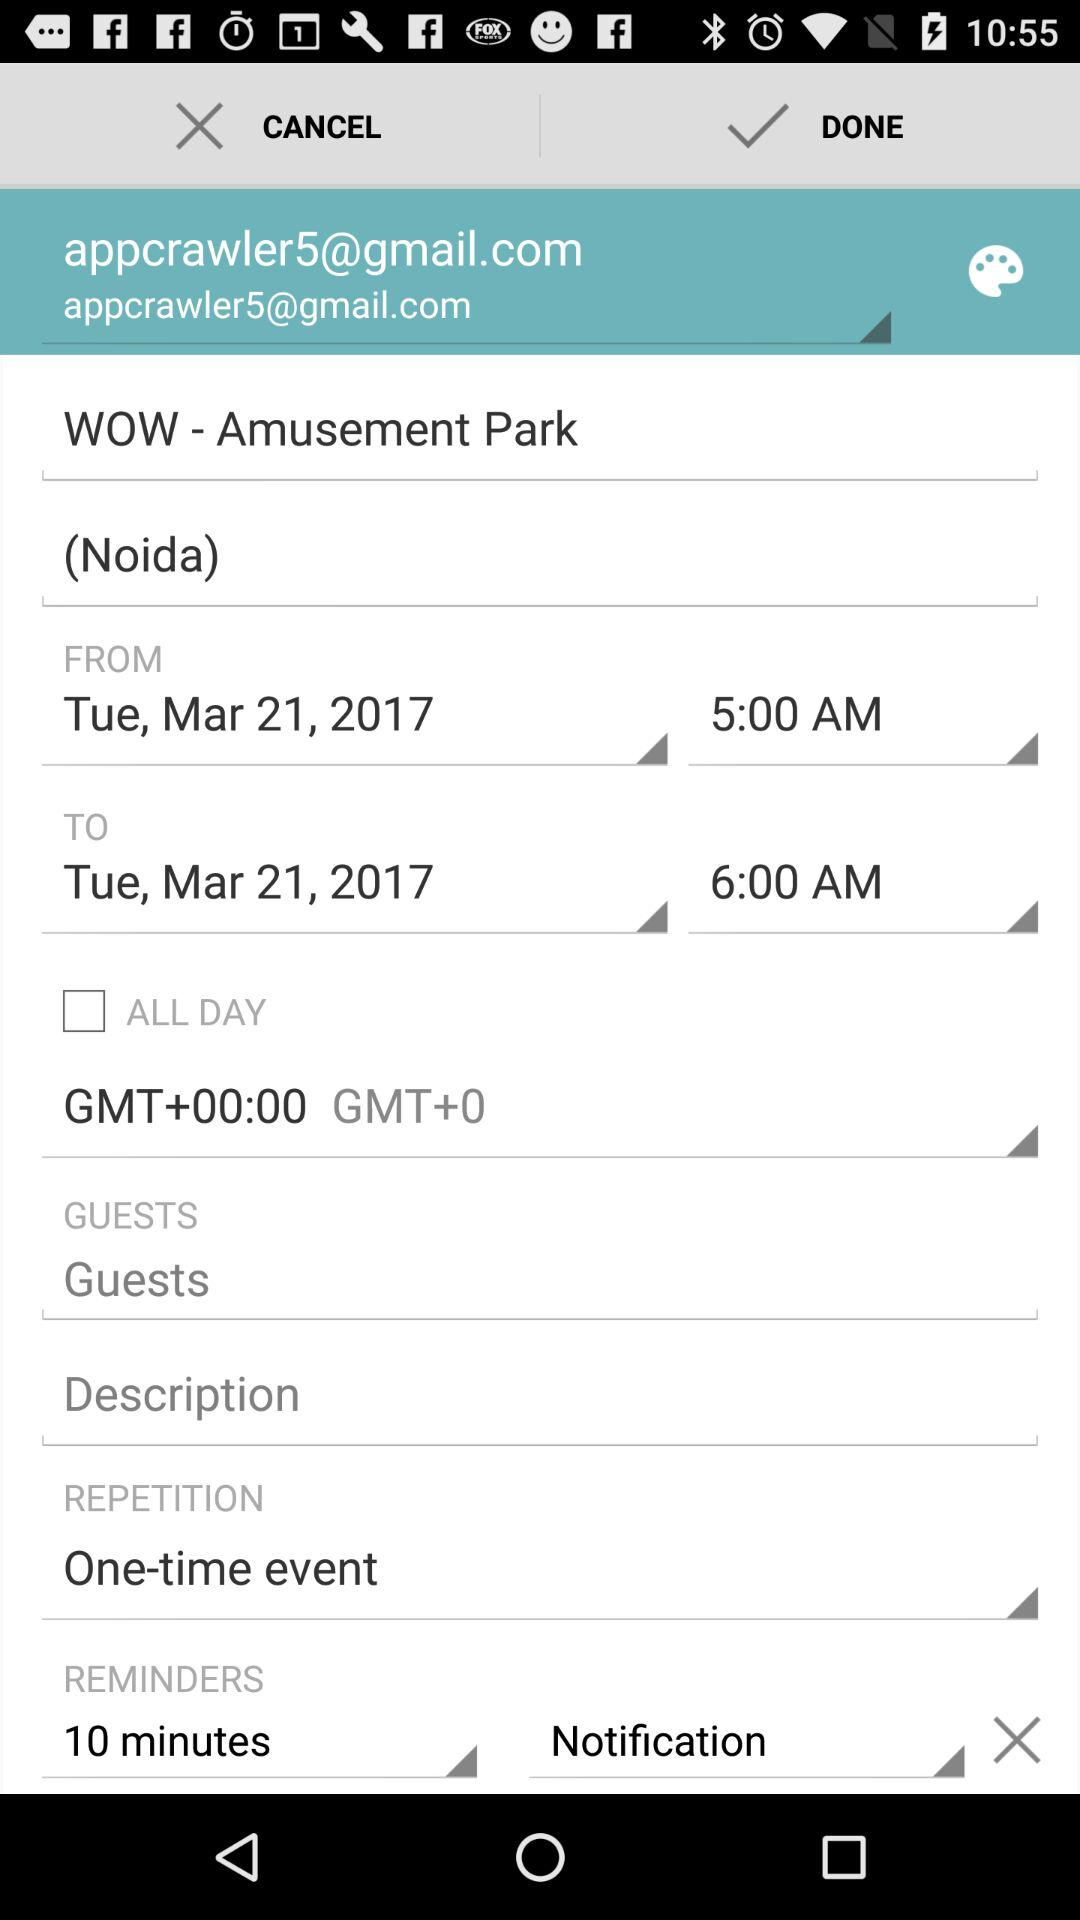What's the Google Mail address? The Google Mail address is appcrawler5@gmail.com. 